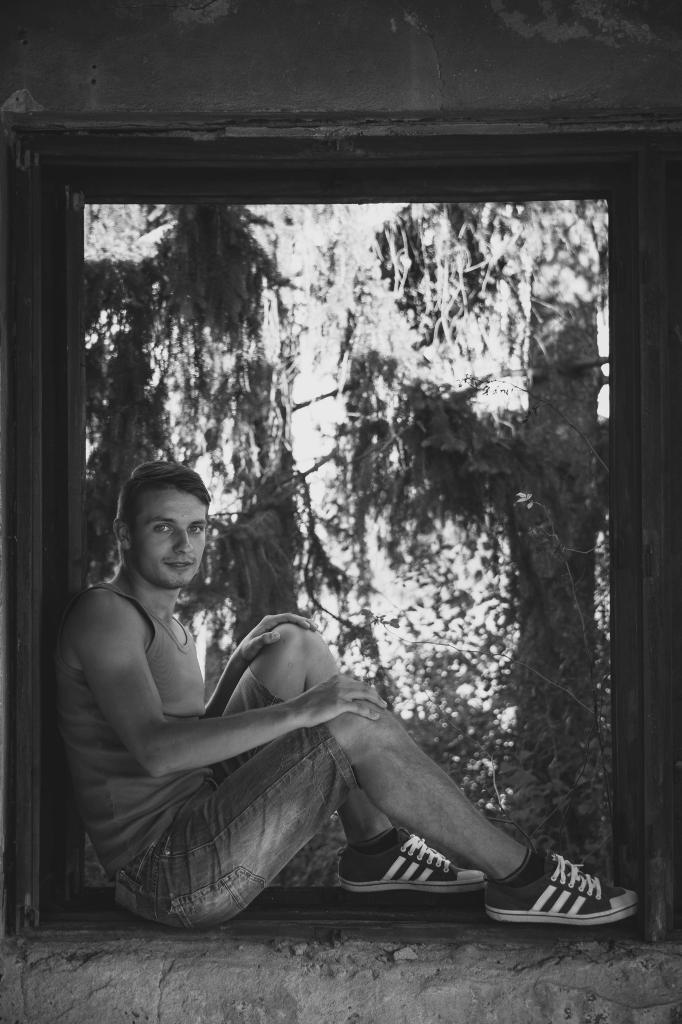Can you describe this image briefly? This is a black and white picture. We can see a man sitting on the wall. He wore shoes. In the background we can see tree trunk and its blur. 